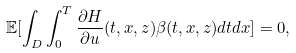<formula> <loc_0><loc_0><loc_500><loc_500>\mathbb { E } [ \int _ { D } \int _ { 0 } ^ { T } \frac { \partial H } { \partial u } ( t , x , z ) \beta ( t , x , z ) d t d x ] = 0 ,</formula> 